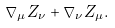<formula> <loc_0><loc_0><loc_500><loc_500>\nabla _ { \mu } Z _ { \nu } + \nabla _ { \nu } Z _ { \mu } .</formula> 